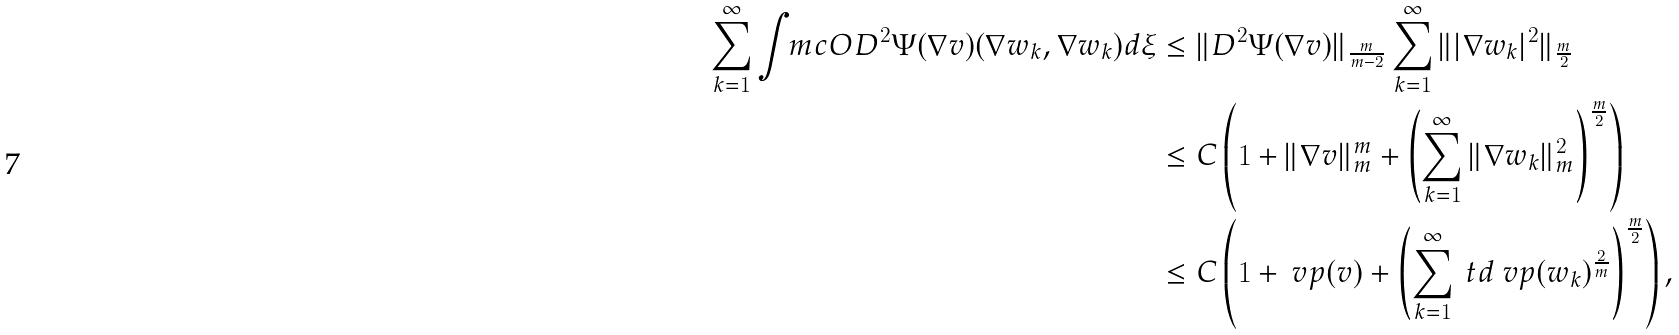Convert formula to latex. <formula><loc_0><loc_0><loc_500><loc_500>\sum _ { k = 1 } ^ { \infty } \int _ { \ } m c O D ^ { 2 } \Psi ( \nabla v ) ( \nabla w _ { k } , \nabla w _ { k } ) d \xi & \leq \| D ^ { 2 } \Psi ( \nabla v ) \| _ { \frac { m } { m - 2 } } \sum _ { k = 1 } ^ { \infty } \| | \nabla w _ { k } | ^ { 2 } \| _ { \frac { m } { 2 } } \\ & \leq C \left ( 1 + \| \nabla v \| _ { m } ^ { m } + \left ( \sum _ { k = 1 } ^ { \infty } \| \nabla w _ { k } \| _ { m } ^ { 2 } \right ) ^ { \frac { m } { 2 } } \right ) \\ & \leq C \left ( 1 + \ v p ( v ) + \left ( \sum _ { k = 1 } ^ { \infty } \ t d \ v p ( w _ { k } ) ^ { \frac { 2 } { m } } \right ) ^ { \frac { m } { 2 } } \right ) ,</formula> 